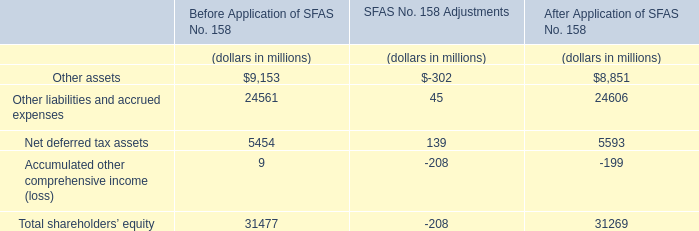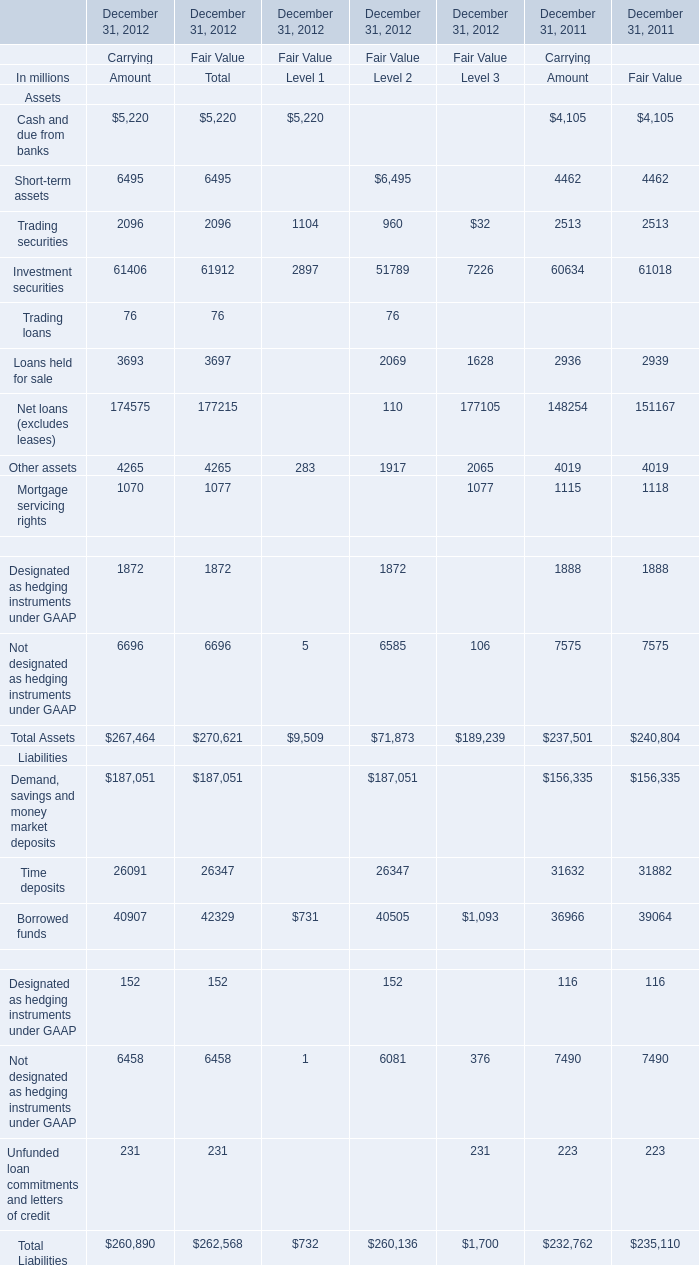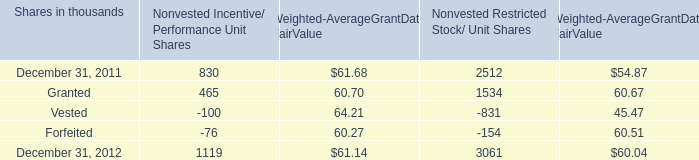What is the sum of Mortgage servicing rights of December 31, 2011 Fair Value, December 31, 2012 of Nonvested Restricted Stock/ Unit Shares, and Investment securities of December 31, 2012 Fair Value Level 1 ? 
Computations: ((1118.0 + 3061.0) + 2897.0)
Answer: 7076.0. 